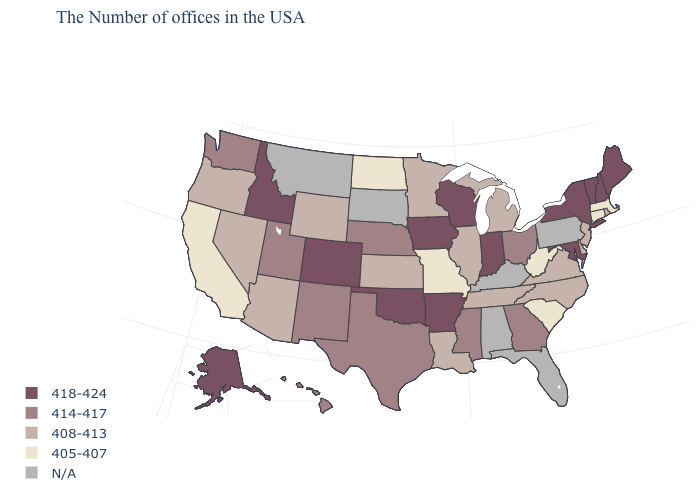What is the highest value in the West ?
Keep it brief. 418-424. What is the value of Vermont?
Give a very brief answer. 418-424. What is the value of Idaho?
Be succinct. 418-424. Which states hav the highest value in the West?
Keep it brief. Colorado, Idaho, Alaska. Name the states that have a value in the range 418-424?
Write a very short answer. Maine, New Hampshire, Vermont, New York, Maryland, Indiana, Wisconsin, Arkansas, Iowa, Oklahoma, Colorado, Idaho, Alaska. What is the value of New York?
Short answer required. 418-424. What is the highest value in the West ?
Short answer required. 418-424. Does South Carolina have the lowest value in the USA?
Write a very short answer. Yes. Which states have the lowest value in the Northeast?
Answer briefly. Massachusetts, Connecticut. Does the map have missing data?
Short answer required. Yes. Name the states that have a value in the range 414-417?
Give a very brief answer. Ohio, Georgia, Mississippi, Nebraska, Texas, New Mexico, Utah, Washington, Hawaii. What is the value of Washington?
Short answer required. 414-417. 